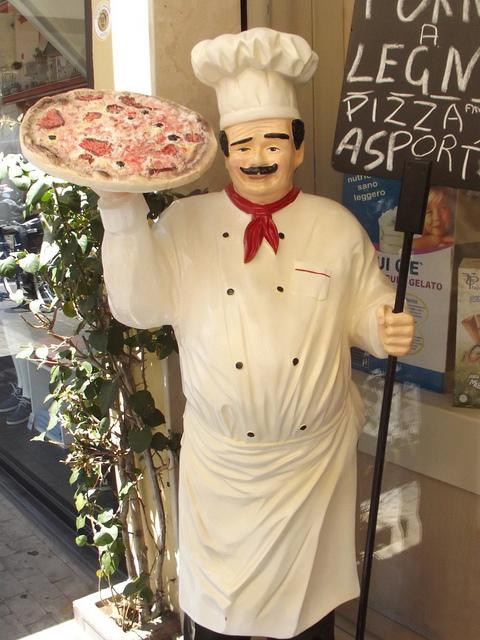What is the statue holding? pizza 